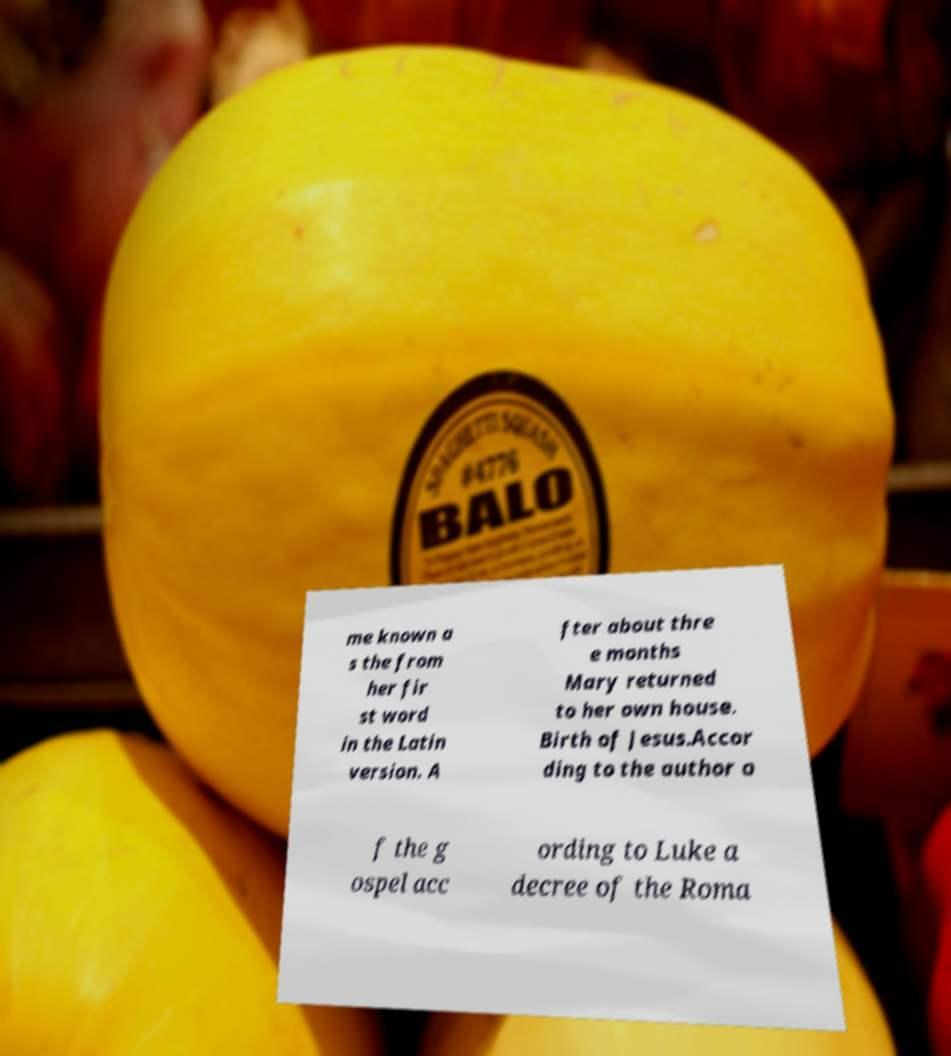I need the written content from this picture converted into text. Can you do that? me known a s the from her fir st word in the Latin version. A fter about thre e months Mary returned to her own house. Birth of Jesus.Accor ding to the author o f the g ospel acc ording to Luke a decree of the Roma 